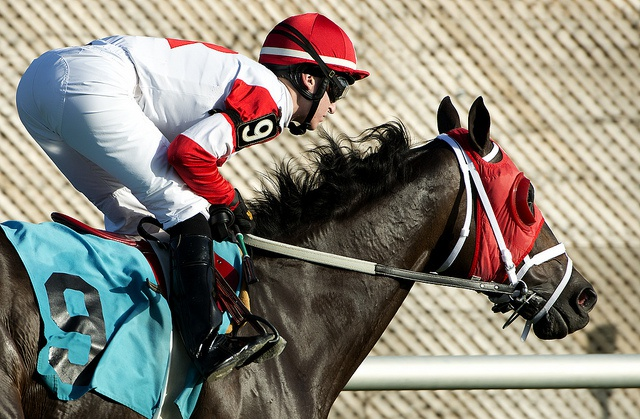Describe the objects in this image and their specific colors. I can see horse in tan, black, gray, and maroon tones and people in tan, white, black, gray, and red tones in this image. 